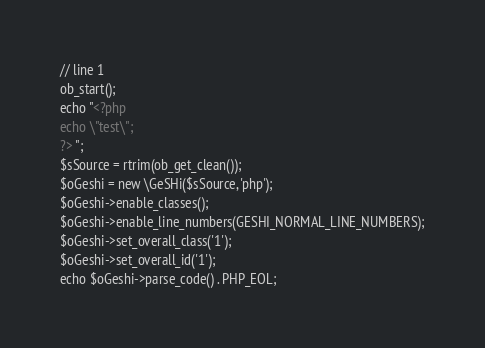Convert code to text. <code><loc_0><loc_0><loc_500><loc_500><_HTML_>// line 1
ob_start();
echo "<?php
echo \"test\";  
?> ";
$sSource = rtrim(ob_get_clean());
$oGeshi = new \GeSHi($sSource, 'php');
$oGeshi->enable_classes();
$oGeshi->enable_line_numbers(GESHI_NORMAL_LINE_NUMBERS);
$oGeshi->set_overall_class('1');
$oGeshi->set_overall_id('1');
echo $oGeshi->parse_code() . PHP_EOL;</code> 